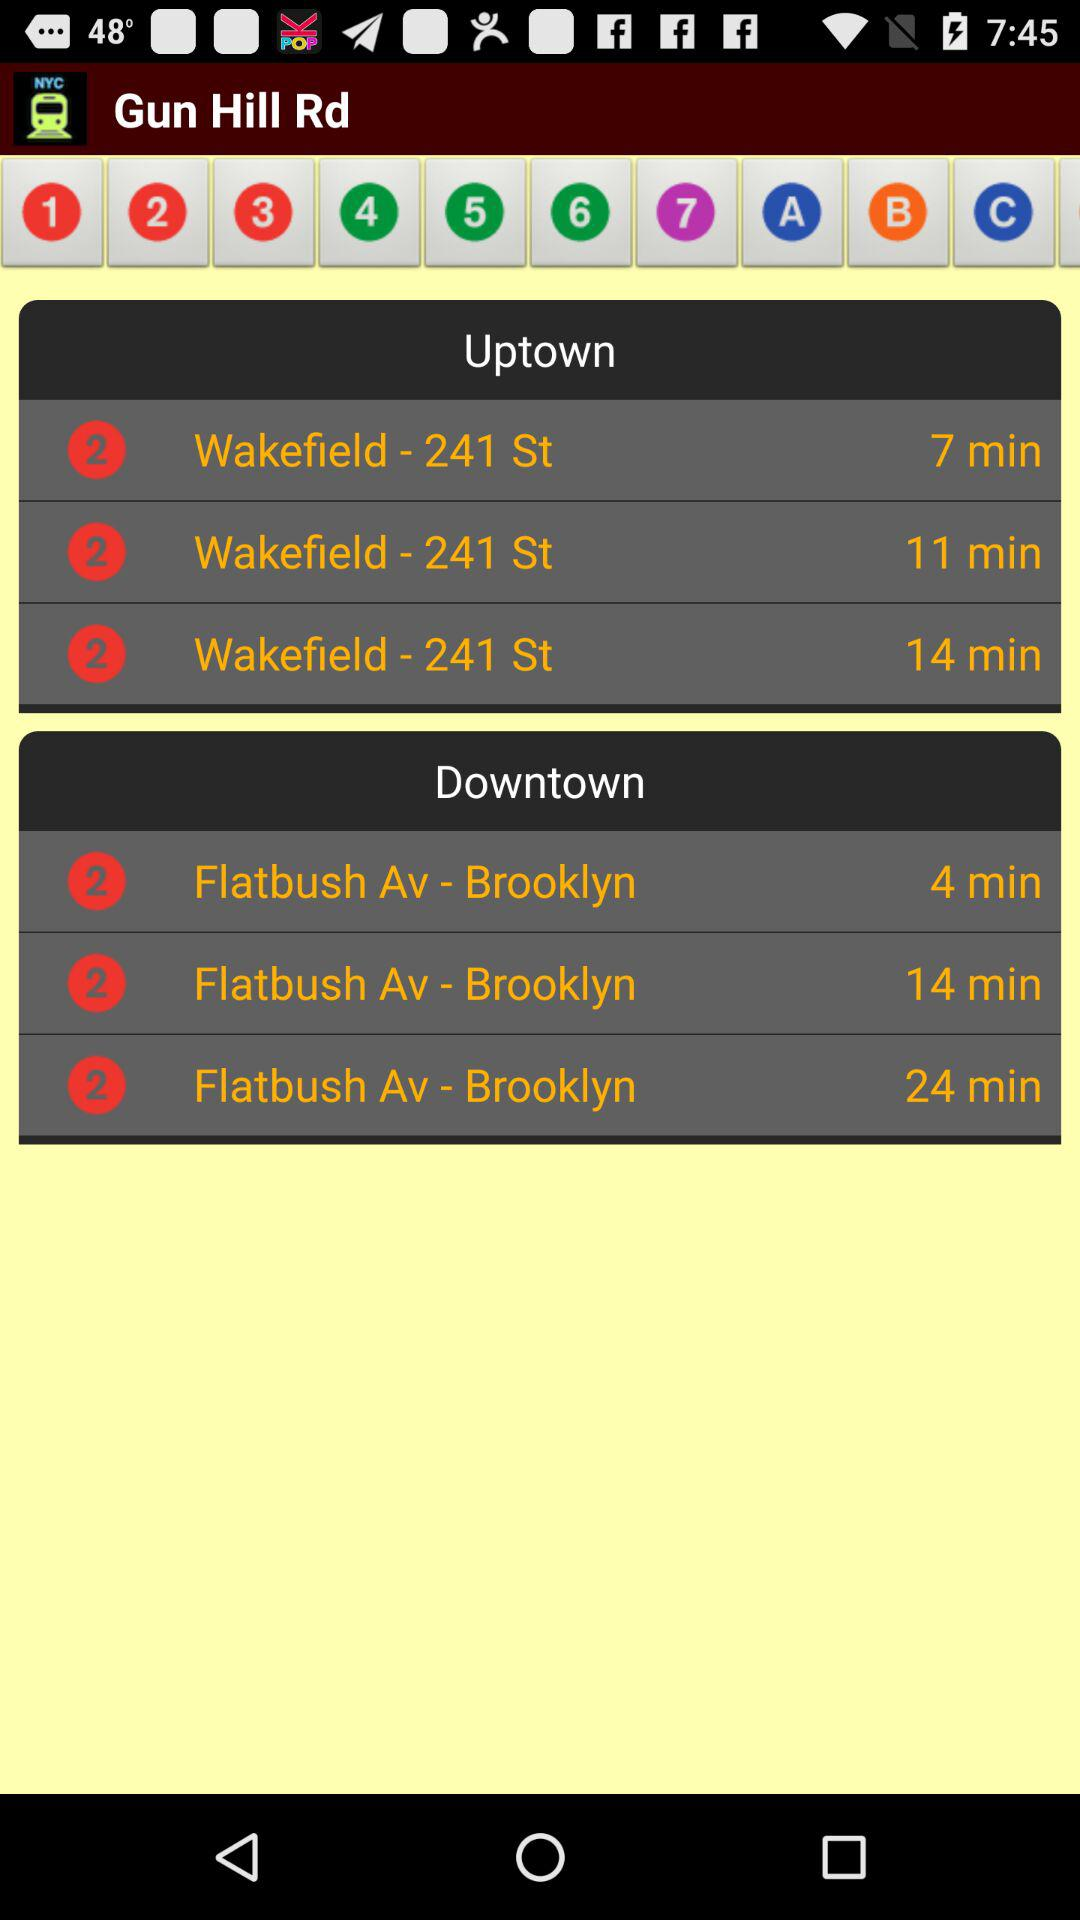What time does downtown open?
When the provided information is insufficient, respond with <no answer>. <no answer> 